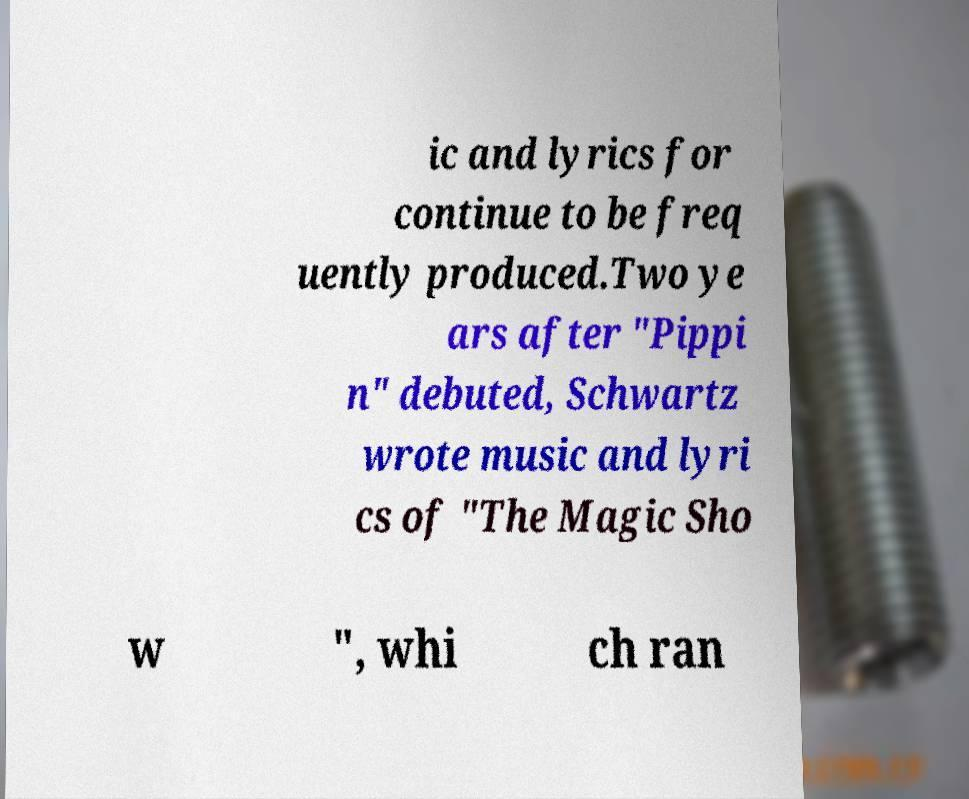Please read and relay the text visible in this image. What does it say? ic and lyrics for continue to be freq uently produced.Two ye ars after "Pippi n" debuted, Schwartz wrote music and lyri cs of "The Magic Sho w ", whi ch ran 